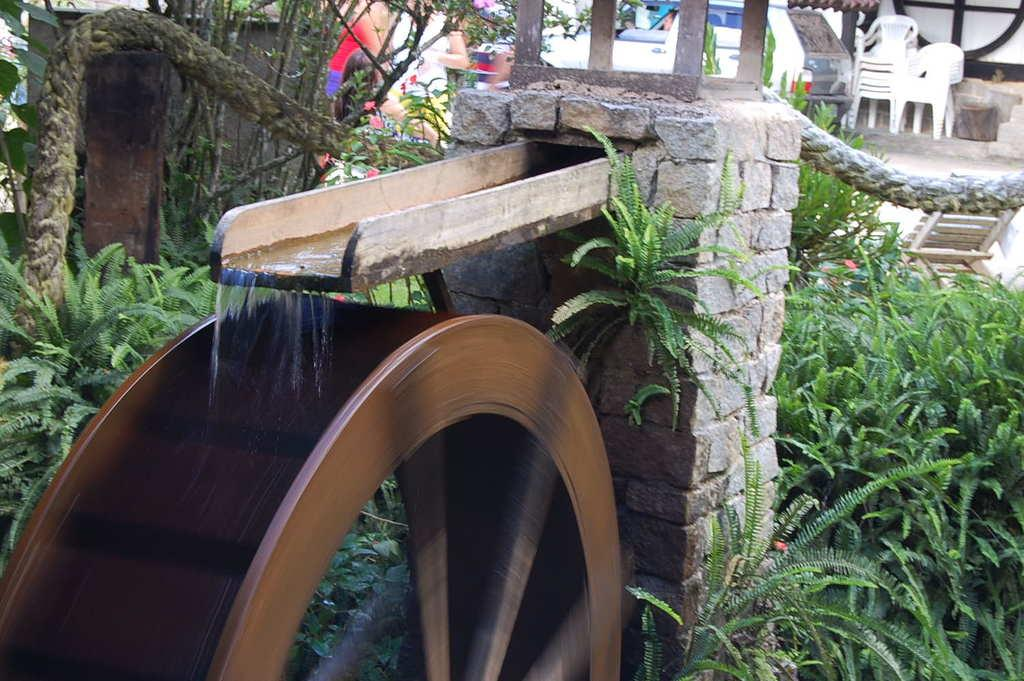What is the main object in the image? There is a wheel in the image. What structures can be seen in the image? There are pillars in the image. What type of vegetation is present in the image? There are plants and trees in the image. What natural element is visible in the image? There is water flow visible in the image. Who or what is at the top of the image? There are people and a vehicle at the top of the image, along with chairs. How far does the distance between the people and the vehicle change in the image? There is no indication of a change in distance between the people and the vehicle in the image. 